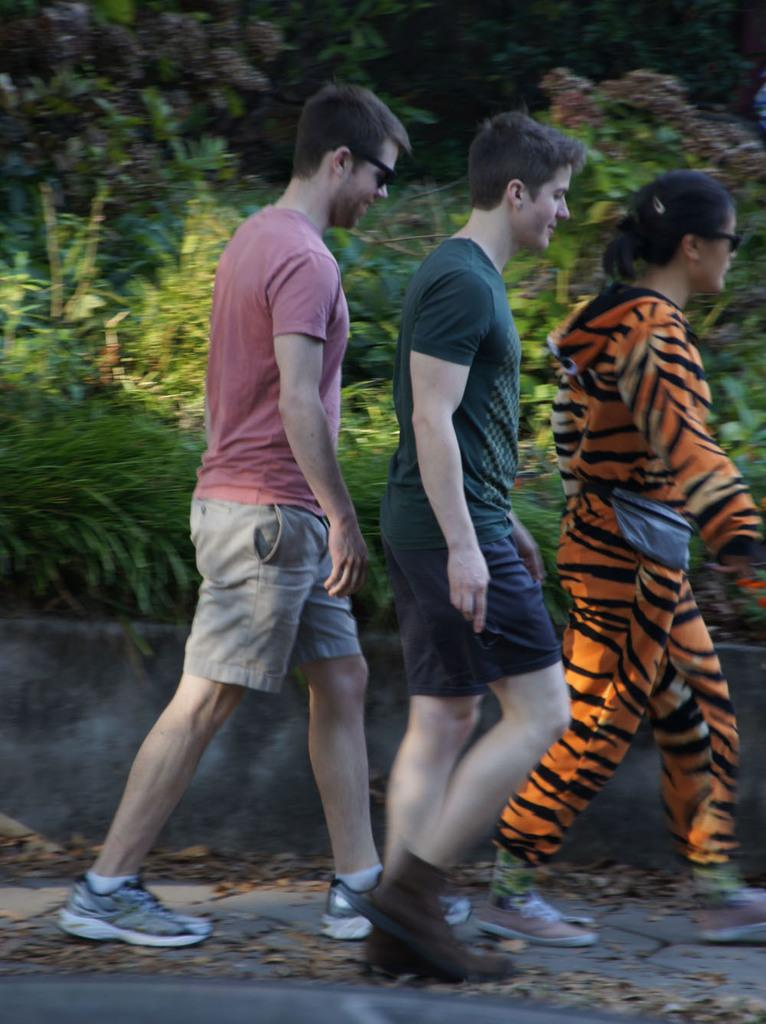How many people are in the image? There are three persons in the image. What are the persons doing in the image? The three persons are walking. What type of footwear are the persons wearing? The persons are wearing shoes. What can be seen in the background of the image? There are trees in the background of the image. Can you see a stem growing from the person's head in the image? No, there is no stem growing from any person's head in the image. Are there any bees or nests visible in the image? No, there are no bees or nests present in the image. 